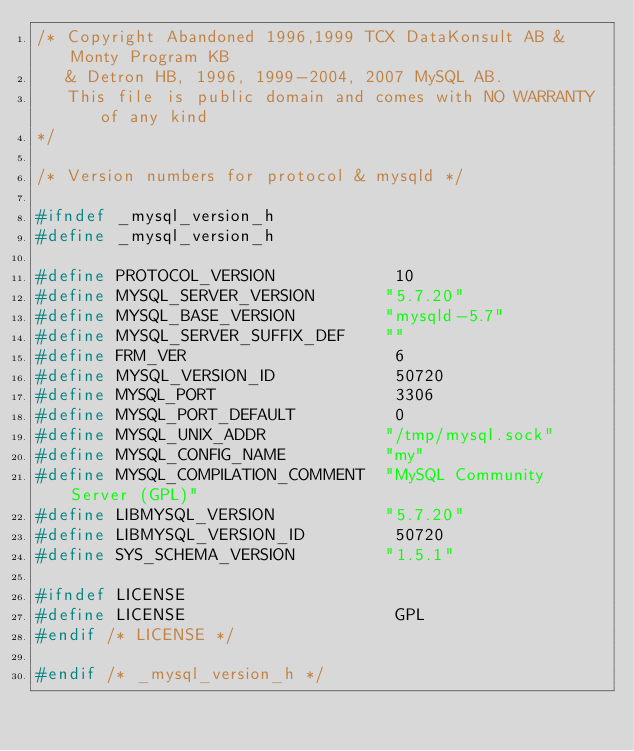<code> <loc_0><loc_0><loc_500><loc_500><_C_>/* Copyright Abandoned 1996,1999 TCX DataKonsult AB & Monty Program KB
   & Detron HB, 1996, 1999-2004, 2007 MySQL AB.
   This file is public domain and comes with NO WARRANTY of any kind
*/

/* Version numbers for protocol & mysqld */

#ifndef _mysql_version_h
#define _mysql_version_h

#define PROTOCOL_VERSION            10
#define MYSQL_SERVER_VERSION       "5.7.20"
#define MYSQL_BASE_VERSION         "mysqld-5.7"
#define MYSQL_SERVER_SUFFIX_DEF    ""
#define FRM_VER                     6
#define MYSQL_VERSION_ID            50720
#define MYSQL_PORT                  3306
#define MYSQL_PORT_DEFAULT          0
#define MYSQL_UNIX_ADDR            "/tmp/mysql.sock"
#define MYSQL_CONFIG_NAME          "my"
#define MYSQL_COMPILATION_COMMENT  "MySQL Community Server (GPL)"
#define LIBMYSQL_VERSION           "5.7.20"
#define LIBMYSQL_VERSION_ID         50720
#define SYS_SCHEMA_VERSION         "1.5.1"

#ifndef LICENSE
#define LICENSE                     GPL
#endif /* LICENSE */

#endif /* _mysql_version_h */
</code> 